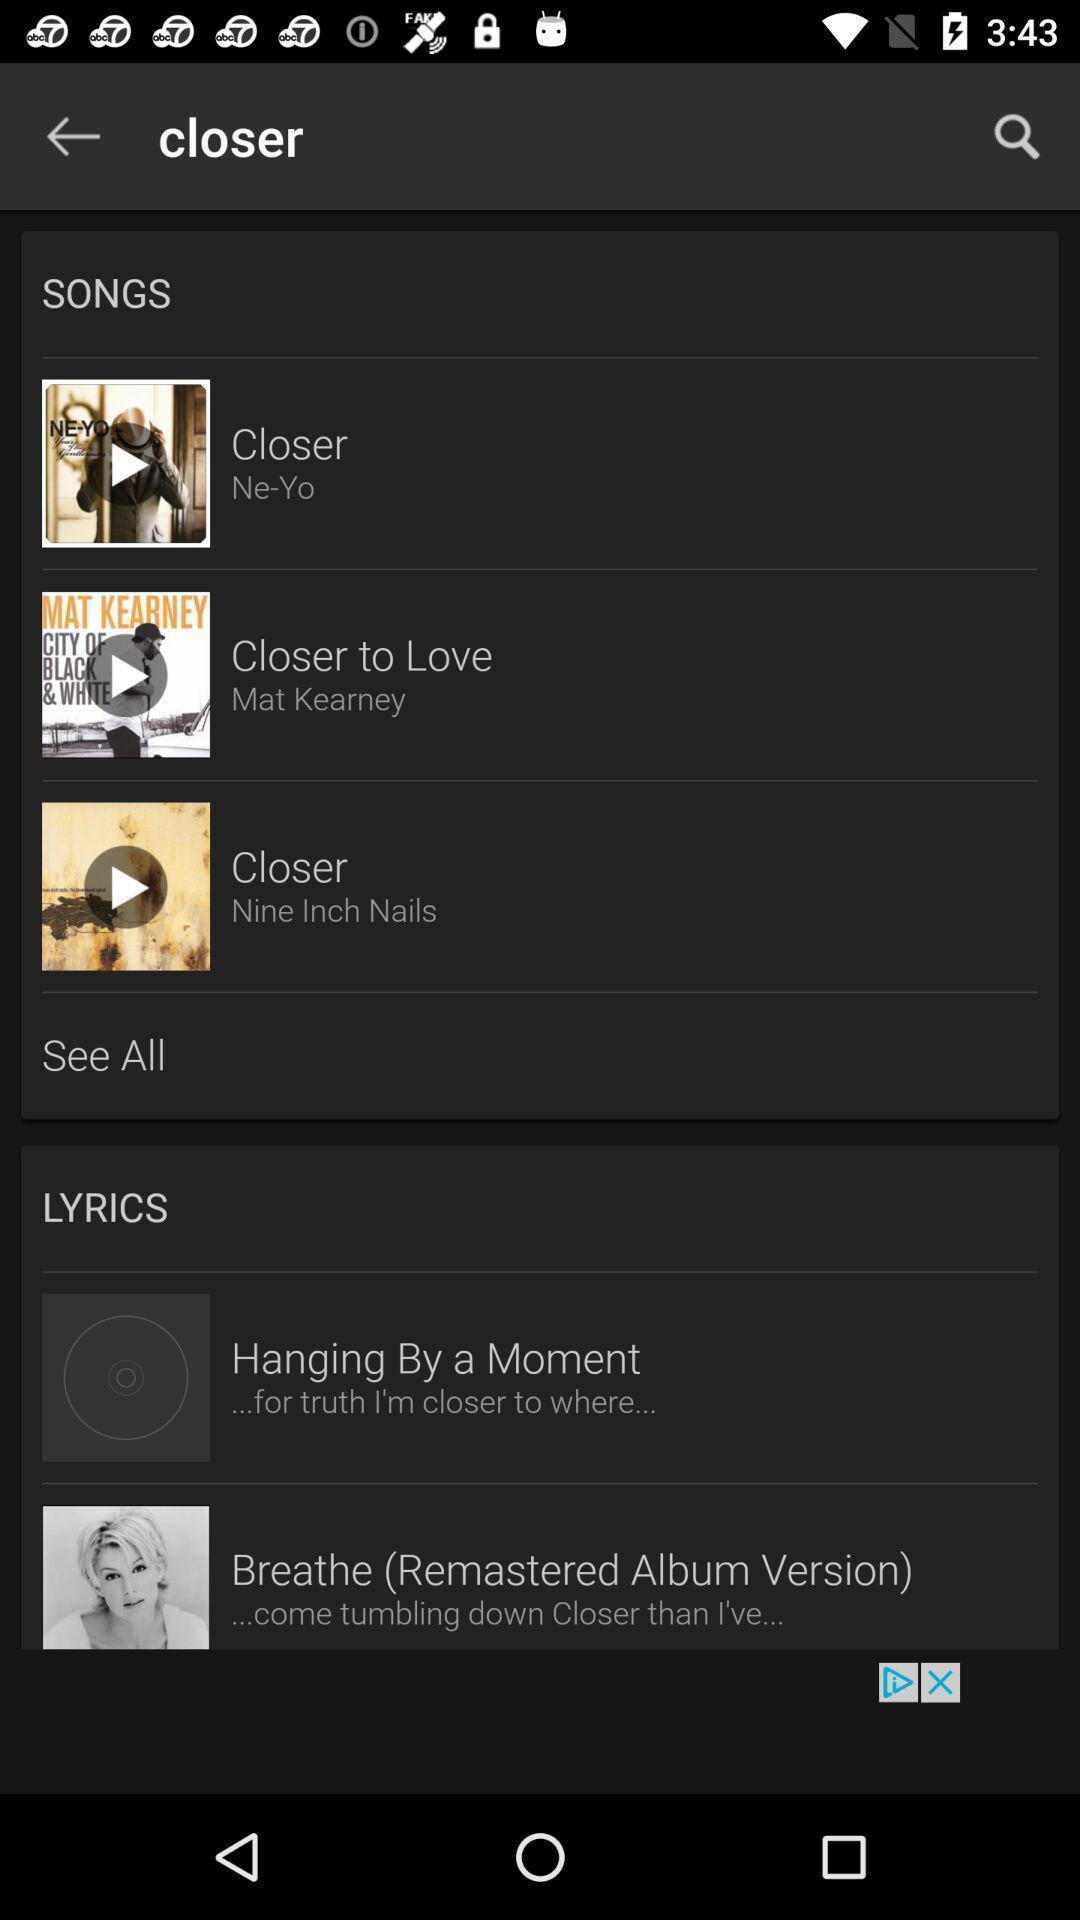Explain what's happening in this screen capture. Screen shows multiple songs in a music application. 